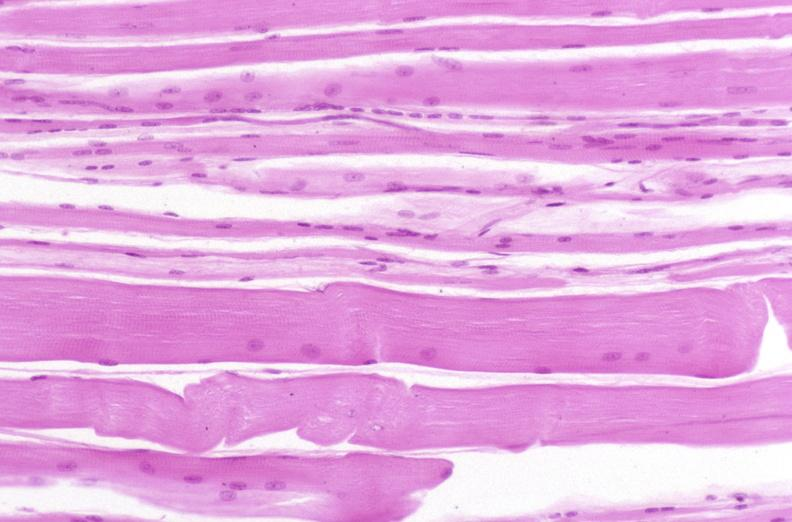s gms present?
Answer the question using a single word or phrase. No 